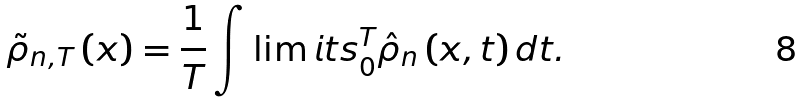<formula> <loc_0><loc_0><loc_500><loc_500>\tilde { \rho } _ { n , T } \left ( x \right ) = \frac { 1 } { T } \int \lim i t s _ { 0 } ^ { T } \hat { \rho } _ { n } \left ( x , t \right ) d t .</formula> 